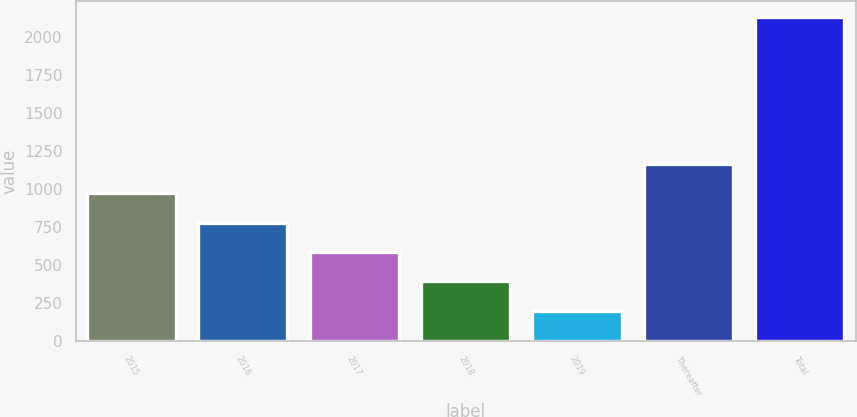Convert chart. <chart><loc_0><loc_0><loc_500><loc_500><bar_chart><fcel>2015<fcel>2016<fcel>2017<fcel>2018<fcel>2019<fcel>Thereafter<fcel>Total<nl><fcel>972.1<fcel>778.8<fcel>585.5<fcel>392.2<fcel>198.9<fcel>1165.4<fcel>2131.9<nl></chart> 